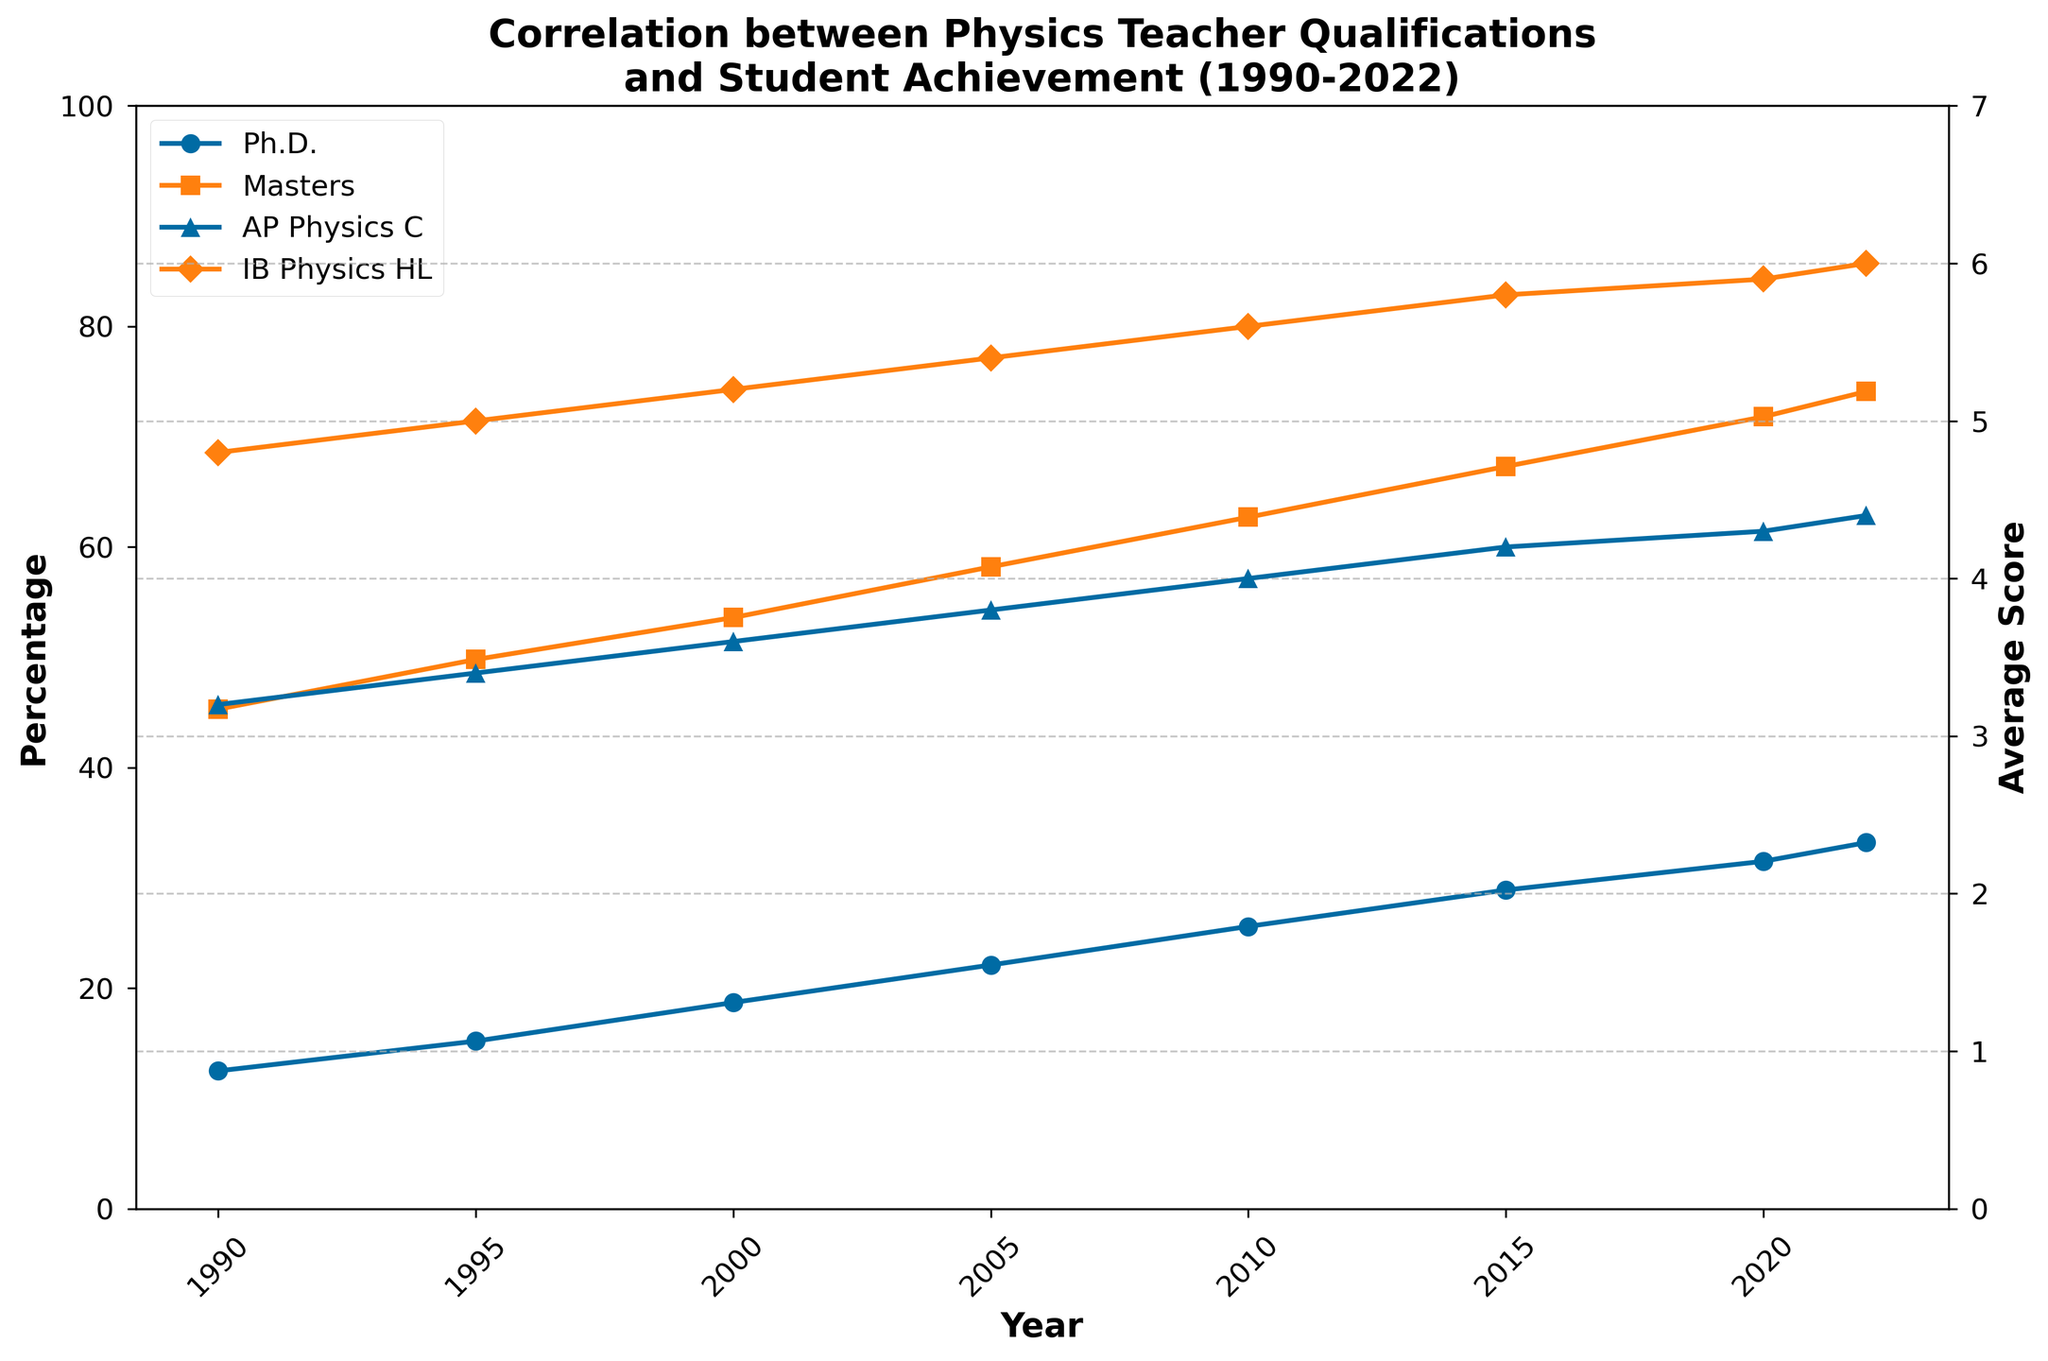What is the trend in the percentage of physics teachers with Ph.D. qualifications from 1990 to 2022? The plot shows an upward trend in the percentage of physics teachers with Ph.D. qualifications. It starts at 12.5% in 1990 and increases consistently until it reaches 33.2% in 2022.
Answer: Upward trend How does the trend in average AP Physics C scores compare to the trend in average IB Physics HL scores from 1990 to 2022? The plot reveals that both the average AP Physics C scores and IB Physics HL scores show an upward trend. AP Physics C scores increase from 3.2 to 4.4, while IB Physics HL scores rise from 4.8 to 6.0.
Answer: Both trends are upward Between 2000 and 2010, by how much did the percentage of teachers with Master's degrees increase? The percentage of teachers with Master's degrees increased from 53.6% in 2000 to 62.7% in 2010. To find the increase: 62.7 - 53.6 = 9.1
Answer: 9.1 In which year did the average AP Physics C scores surpass 4.0? The plot shows that the average AP Physics C scores surpassed 4.0 in 2010.
Answer: 2010 Compare the change in percentage points of teachers with Ph.D. qualifications to those with Master's degrees between 2015 and 2022. The percentage of teachers with Ph.D. qualifications increased from 28.9% in 2015 to 33.2% in 2022 (33.2 - 28.9 = 4.3). For Master’s degrees, it went from 67.3% to 74.1% (74.1 - 67.3 = 6.8).
Answer: Ph.D.: 4.3, Master's: 6.8 In which year did the average IB Physics HL score reach 5.6 or higher? The plot shows that the average IB Physics HL score reached 5.6 in 2010.
Answer: 2010 Which year shows the highest percentage of teachers with Master's qualifications, and what is that percentage? The plot indicates that the highest percentage of teachers with Master's qualifications is in 2022, at 74.1%.
Answer: 2022, 74.1% What is the difference in average AP Physics C scores between 1990 and 2022? The average AP Physics C score in 1990 was 3.2, and it increased to 4.4 in 2022. The difference is 4.4 - 3.2 = 1.2.
Answer: 1.2 By how much did the average score of IB Physics HL change from 1990 to 2022? The average score of IB Physics HL was 4.8 in 1990 and increased to 6.0 in 2022. The change is 6.0 - 4.8 = 1.2.
Answer: 1.2 